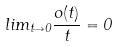<formula> <loc_0><loc_0><loc_500><loc_500>l i m _ { t \rightarrow 0 } \frac { o ( t ) } { t } = 0</formula> 